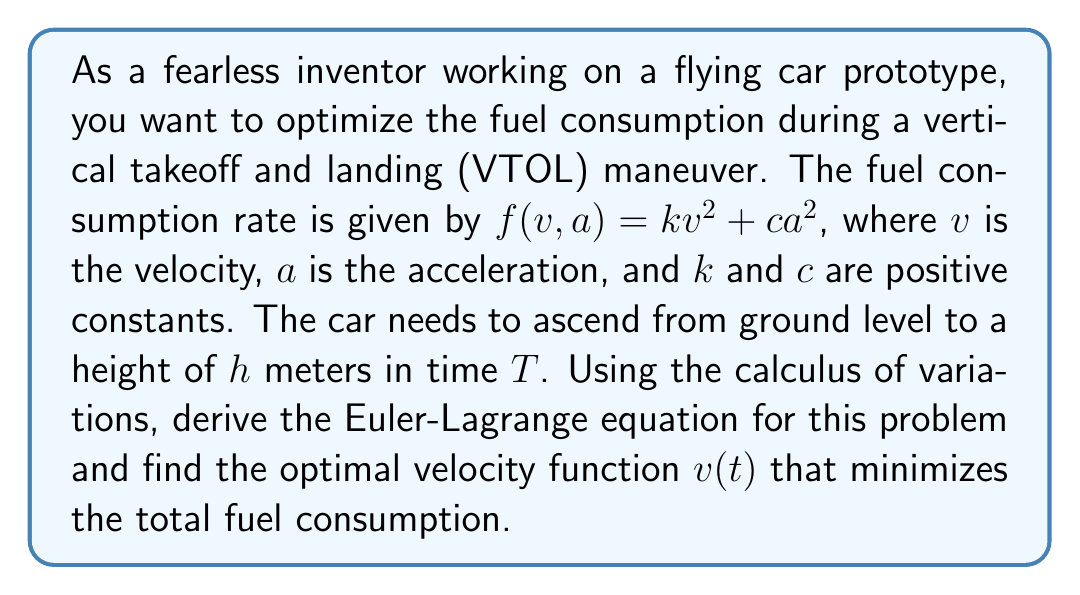Can you answer this question? Let's approach this problem step-by-step using the calculus of variations:

1) The functional to be minimized is the total fuel consumption:

   $$J[v(t)] = \int_0^T (kv^2 + ca^2) dt$$

2) We know that $a = \frac{dv}{dt}$, so we can rewrite the functional as:

   $$J[v(t)] = \int_0^T \left(kv^2 + c\left(\frac{dv}{dt}\right)^2\right) dt$$

3) The Euler-Lagrange equation for this problem is:

   $$\frac{\partial F}{\partial v} - \frac{d}{dt}\left(\frac{\partial F}{\partial v'}\right) = 0$$

   where $F = kv^2 + c(v')^2$ and $v' = \frac{dv}{dt}$

4) Calculating the partial derivatives:

   $$\frac{\partial F}{\partial v} = 2kv$$
   $$\frac{\partial F}{\partial v'} = 2cv'$$

5) Substituting into the Euler-Lagrange equation:

   $$2kv - \frac{d}{dt}(2cv') = 0$$

6) Simplifying:

   $$2kv - 2cv'' = 0$$
   $$kv - cv'' = 0$$

7) This is a second-order linear differential equation. The general solution is:

   $$v(t) = A e^{\sqrt{\frac{k}{c}}t} + B e^{-\sqrt{\frac{k}{c}}t}$$

   where $A$ and $B$ are constants to be determined from the boundary conditions.

8) The boundary conditions are:

   At $t = 0$, $v(0) = 0$ (starting from rest)
   At $t = T$, $v(T) = 0$ (ending at rest)
   $\int_0^T v(t) dt = h$ (total distance traveled)

9) Applying the first two conditions:

   $0 = A + B$
   $0 = A e^{\sqrt{\frac{k}{c}}T} + B e^{-\sqrt{\frac{k}{c}}T}$

   This gives us $A = -B$ and $A = B e^{-\sqrt{\frac{k}{c}}T}$

10) Solving these:

    $A = \frac{h\sqrt{\frac{k}{c}}}{2\sinh(\sqrt{\frac{k}{c}}T)}$
    $B = -\frac{h\sqrt{\frac{k}{c}}}{2\sinh(\sqrt{\frac{k}{c}}T)}$

11) Therefore, the optimal velocity function is:

    $$v(t) = \frac{h\sqrt{\frac{k}{c}}}{2\sinh(\sqrt{\frac{k}{c}}T)} \left(e^{\sqrt{\frac{k}{c}}t} - e^{-\sqrt{\frac{k}{c}}t}\right)$$

    $$= \frac{h\sqrt{\frac{k}{c}}}{\sinh(\sqrt{\frac{k}{c}}T)} \sinh\left(\sqrt{\frac{k}{c}}t\right)$$
Answer: The optimal velocity function that minimizes fuel consumption is:

$$v(t) = \frac{h\sqrt{\frac{k}{c}}}{\sinh(\sqrt{\frac{k}{c}}T)} \sinh\left(\sqrt{\frac{k}{c}}t\right)$$

where $h$ is the height to be reached, $T$ is the total time, and $k$ and $c$ are the constants in the fuel consumption rate equation. 